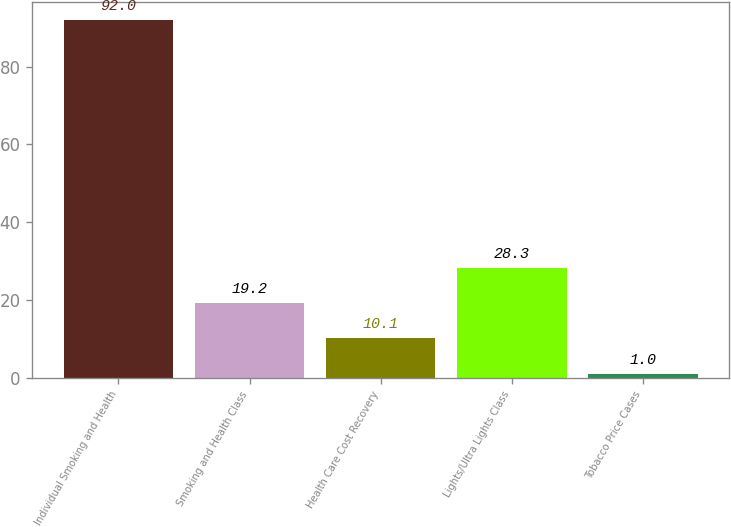Convert chart. <chart><loc_0><loc_0><loc_500><loc_500><bar_chart><fcel>Individual Smoking and Health<fcel>Smoking and Health Class<fcel>Health Care Cost Recovery<fcel>Lights/Ultra Lights Class<fcel>Tobacco Price Cases<nl><fcel>92<fcel>19.2<fcel>10.1<fcel>28.3<fcel>1<nl></chart> 